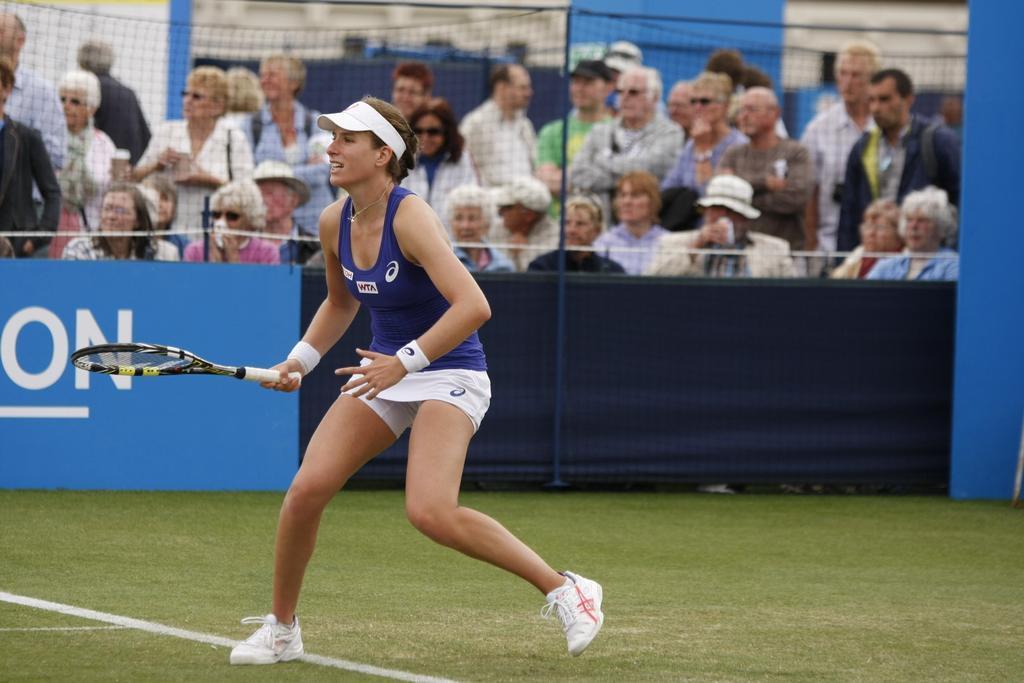Can you describe this image briefly? As we can see in the image there are few people over here and the women who is standing here is holding shuttle bat. 